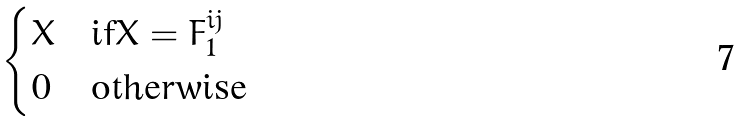Convert formula to latex. <formula><loc_0><loc_0><loc_500><loc_500>\begin{cases} X & \text {if} X = F _ { 1 } ^ { i j } \\ 0 & \text {otherwise} \end{cases}</formula> 